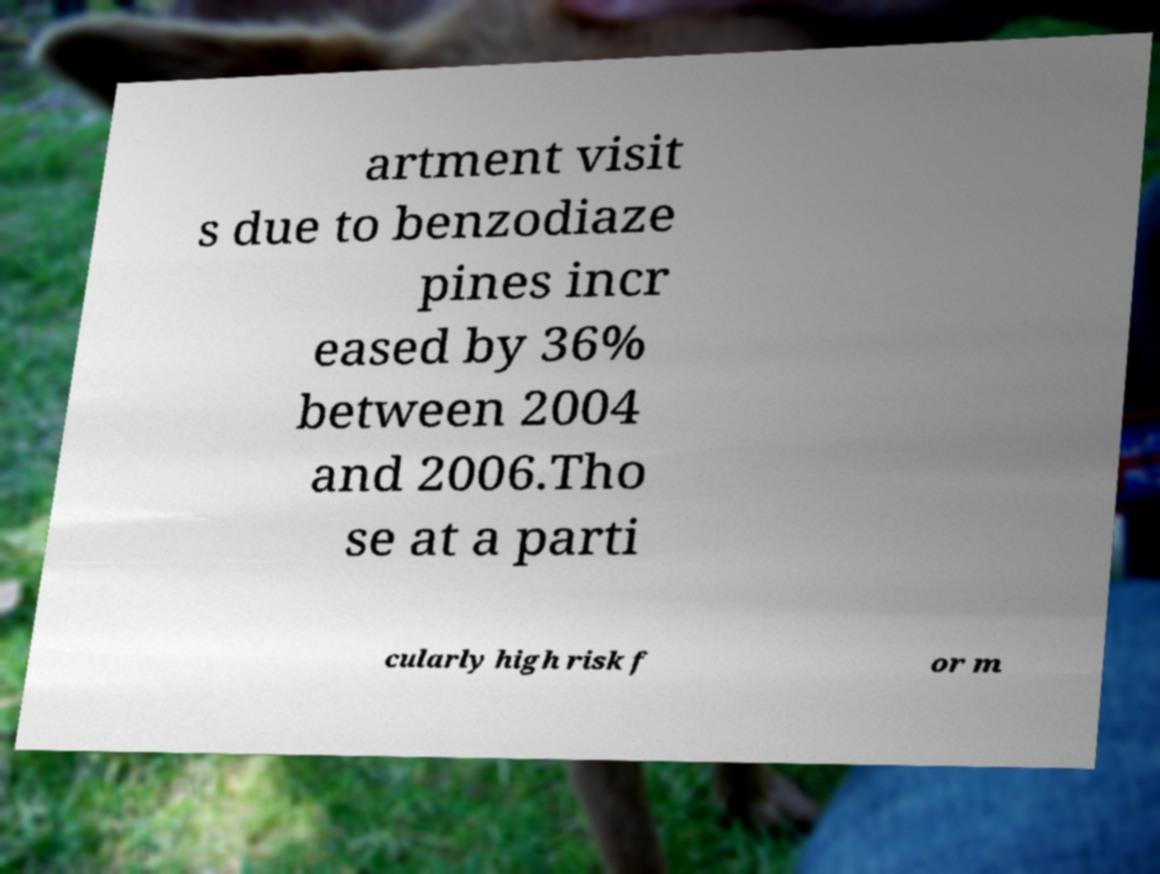Could you extract and type out the text from this image? artment visit s due to benzodiaze pines incr eased by 36% between 2004 and 2006.Tho se at a parti cularly high risk f or m 